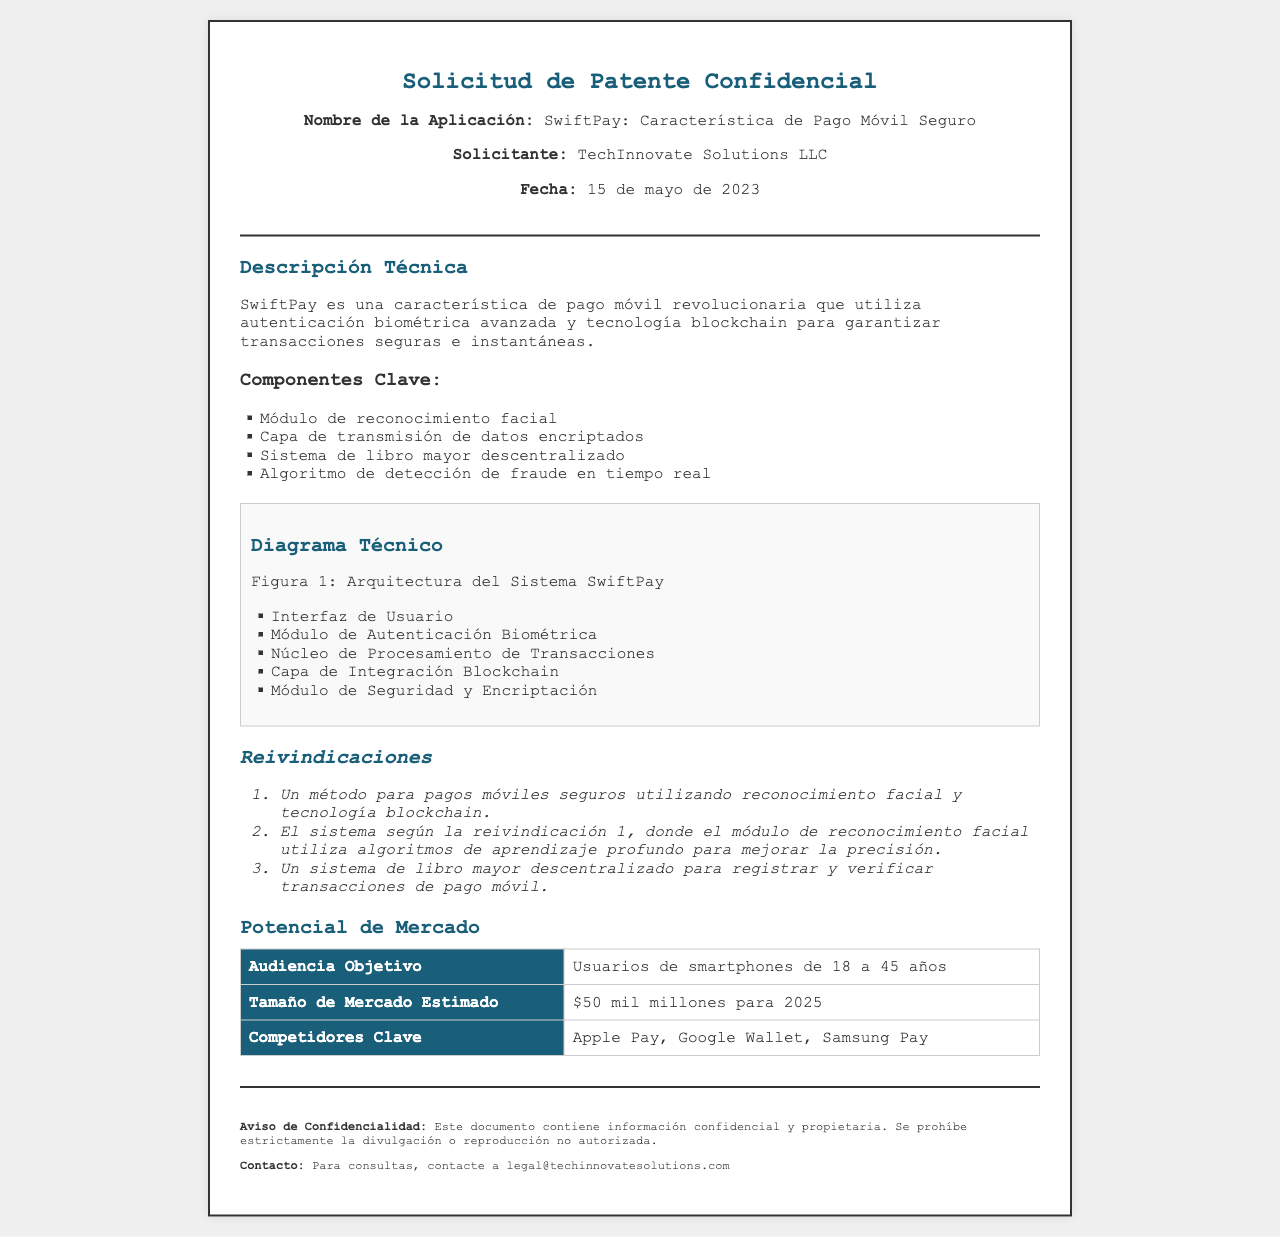¿Qué es SwiftPay? SwiftPay es la característica de pago móvil seguro presentada en la solicitud de patente.
Answer: Característica de Pago Móvil Seguro ¿Cuál es la fecha de presentación de la solicitud? La fecha indicada en el documento es el 15 de mayo de 2023.
Answer: 15 de mayo de 2023 ¿Cuál es el tamaño del mercado estimado para 2025? El documento menciona que el tamaño del mercado estimado es de 50 mil millones de dólares para 2025.
Answer: 50 mil millones ¿Qué tecnología utiliza SwiftPay para las transacciones? Se menciona el uso de autenticación biométrica avanzada y tecnología blockchain para las transacciones.
Answer: Autenticación biométrica y tecnología blockchain ¿Cuál es el público objetivo de la aplicación? La audiencia objetivo abarca a los usuarios de smartphones de edades entre 18 y 45 años.
Answer: Usuarios de smartphones de 18 a 45 años ¿Cómo se asegura la precisión en el reconocimiento facial? La precisión mejora mediante el uso de algoritmos de aprendizaje profundo, según la reivindicación 2.
Answer: Algoritmos de aprendizaje profundo ¿Cuál es el primer elemento de la lista de reivindicaciones? El primer elemento de las reivindicaciones menciona el método para pagos móviles seguros.
Answer: Un método para pagos móviles seguros ¿Qué componentes clave se mencionan en la descripción técnica? En la descripción técnica se indican varios componentes clave, como el módulo de reconocimiento facial y la capa de transmisión de datos encriptados.
Answer: Módulo de reconocimiento facial, capa de transmisión de datos encriptados ¿Quién es el solicitante de la patente? El solicitante indicado en el documento es TechInnovate Solutions LLC.
Answer: TechInnovate Solutions LLC 